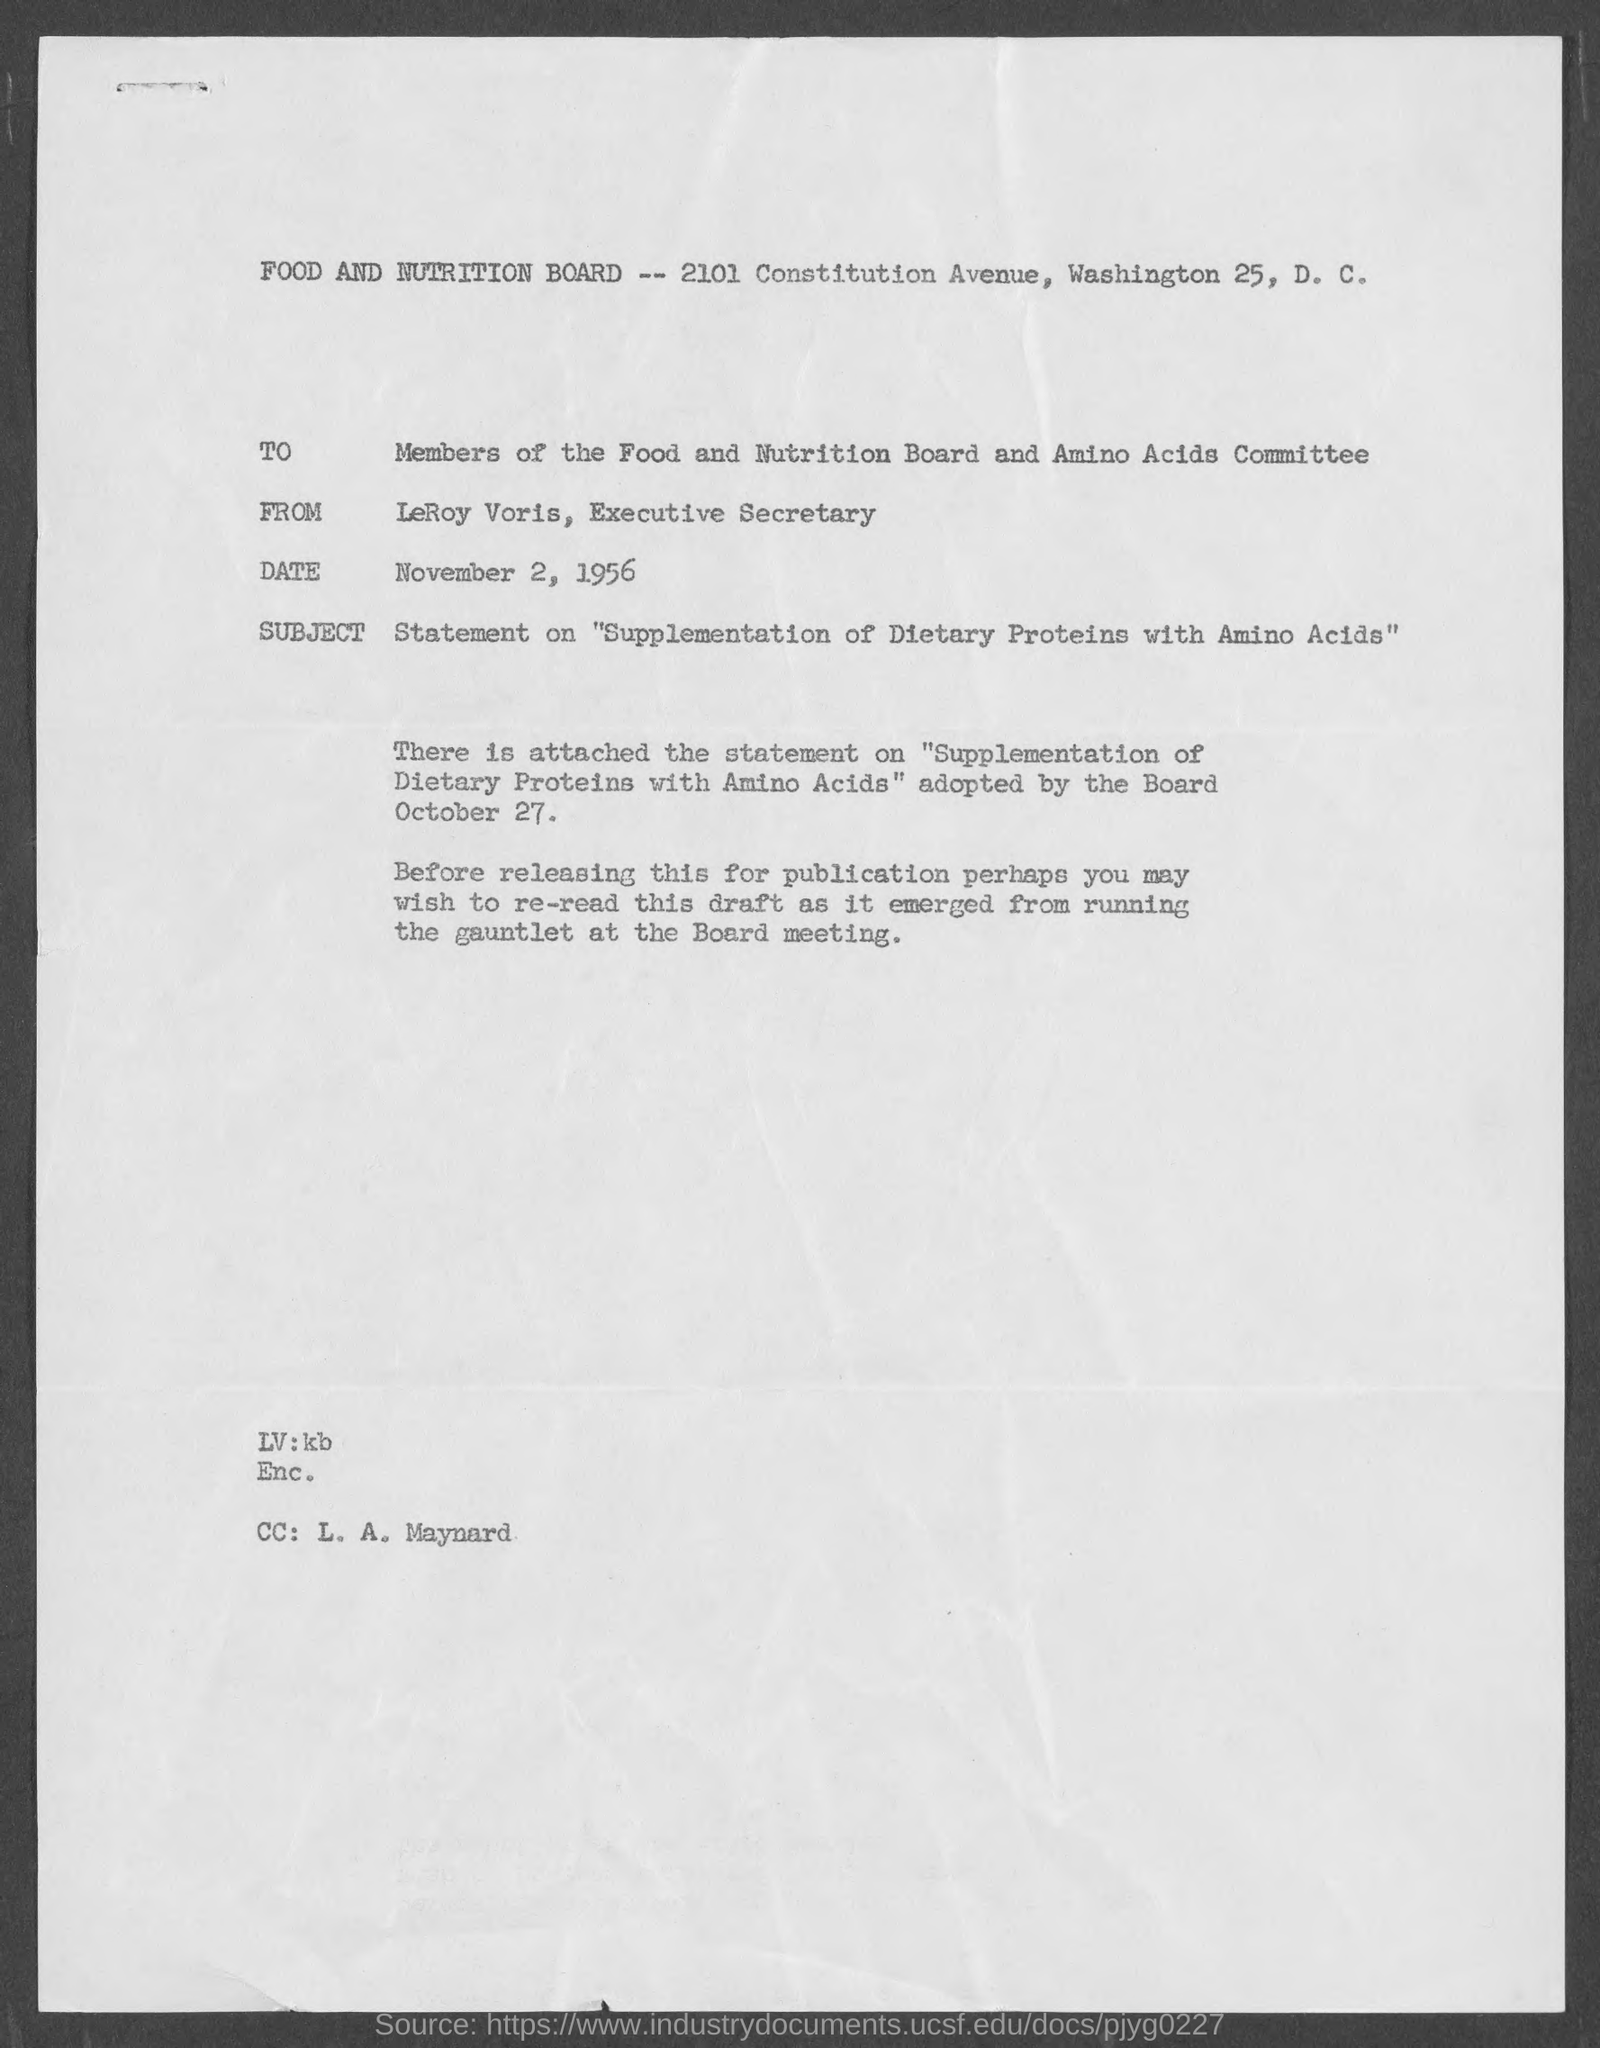Identify some key points in this picture. The date is November 2, 1956. The letter is addressed to the members of the Food and Nutrition Board and Amino Acids Committee. 